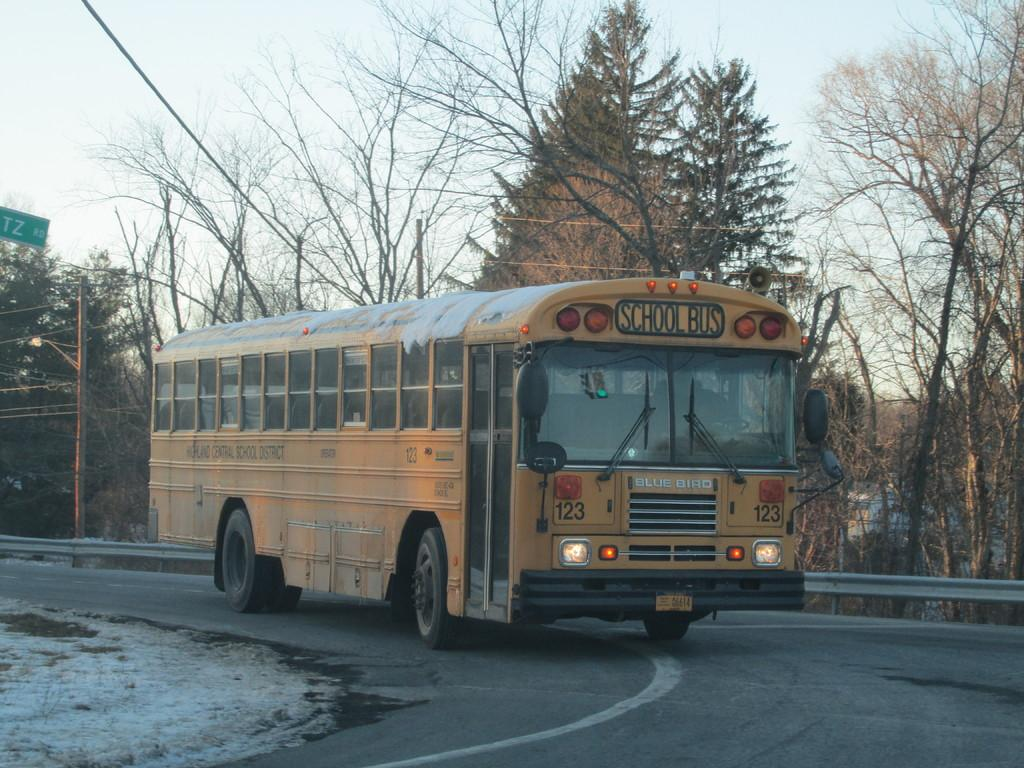What is the main subject in the center of the image? There is a yellow bus in the center of the image. What can be seen on the bus? The bus has some text on it. What is the bus doing in the image? The bus is moving on the road. What can be seen in the background of the image? There are trees and a metal fence in the background of the image. What type of fruit is being carried by the secretary in the image? There is no secretary or fruit present in the image. The main subject is a yellow bus moving on the road. 